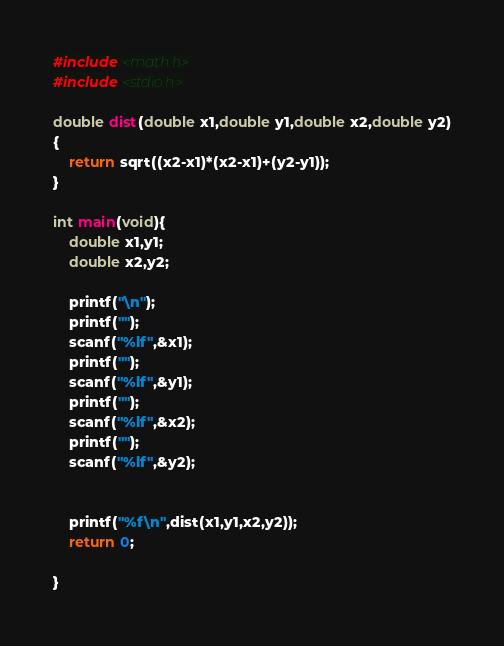<code> <loc_0><loc_0><loc_500><loc_500><_C_>#include <math.h>
#include <stdio.h>

double dist(double x1,double y1,double x2,double y2)
{
    return sqrt((x2-x1)*(x2-x1)+(y2-y1));
}

int main(void){
    double x1,y1;
    double x2,y2;
    
    printf("\n");
    printf("");
    scanf("%lf",&x1);
    printf("");
    scanf("%lf",&y1);
    printf("");
    scanf("%lf",&x2);
    printf("");
    scanf("%lf",&y2);
    
    
    printf("%f\n",dist(x1,y1,x2,y2));
    return 0;
    
}
</code> 